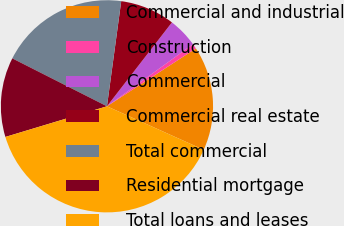Convert chart to OTSL. <chart><loc_0><loc_0><loc_500><loc_500><pie_chart><fcel>Commercial and industrial<fcel>Construction<fcel>Commercial<fcel>Commercial real estate<fcel>Total commercial<fcel>Residential mortgage<fcel>Total loans and leases<nl><fcel>15.91%<fcel>0.77%<fcel>4.56%<fcel>8.34%<fcel>19.69%<fcel>12.12%<fcel>38.61%<nl></chart> 